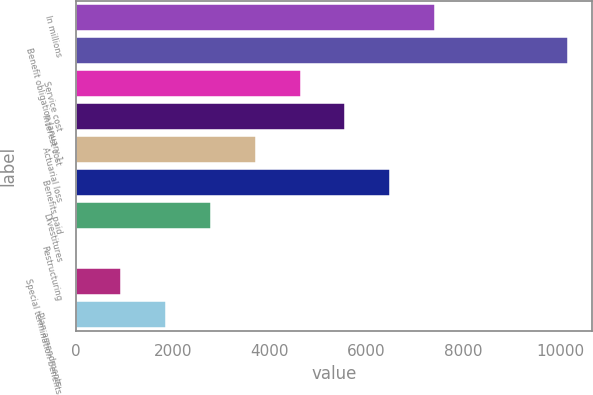Convert chart. <chart><loc_0><loc_0><loc_500><loc_500><bar_chart><fcel>In millions<fcel>Benefit obligation January 1<fcel>Service cost<fcel>Interest cost<fcel>Actuarial loss<fcel>Benefits paid<fcel>Divestitures<fcel>Restructuring<fcel>Special termination benefits<fcel>Plan amendments<nl><fcel>7422.8<fcel>10164.6<fcel>4640<fcel>5567.6<fcel>3712.4<fcel>6495.2<fcel>2784.8<fcel>2<fcel>929.6<fcel>1857.2<nl></chart> 